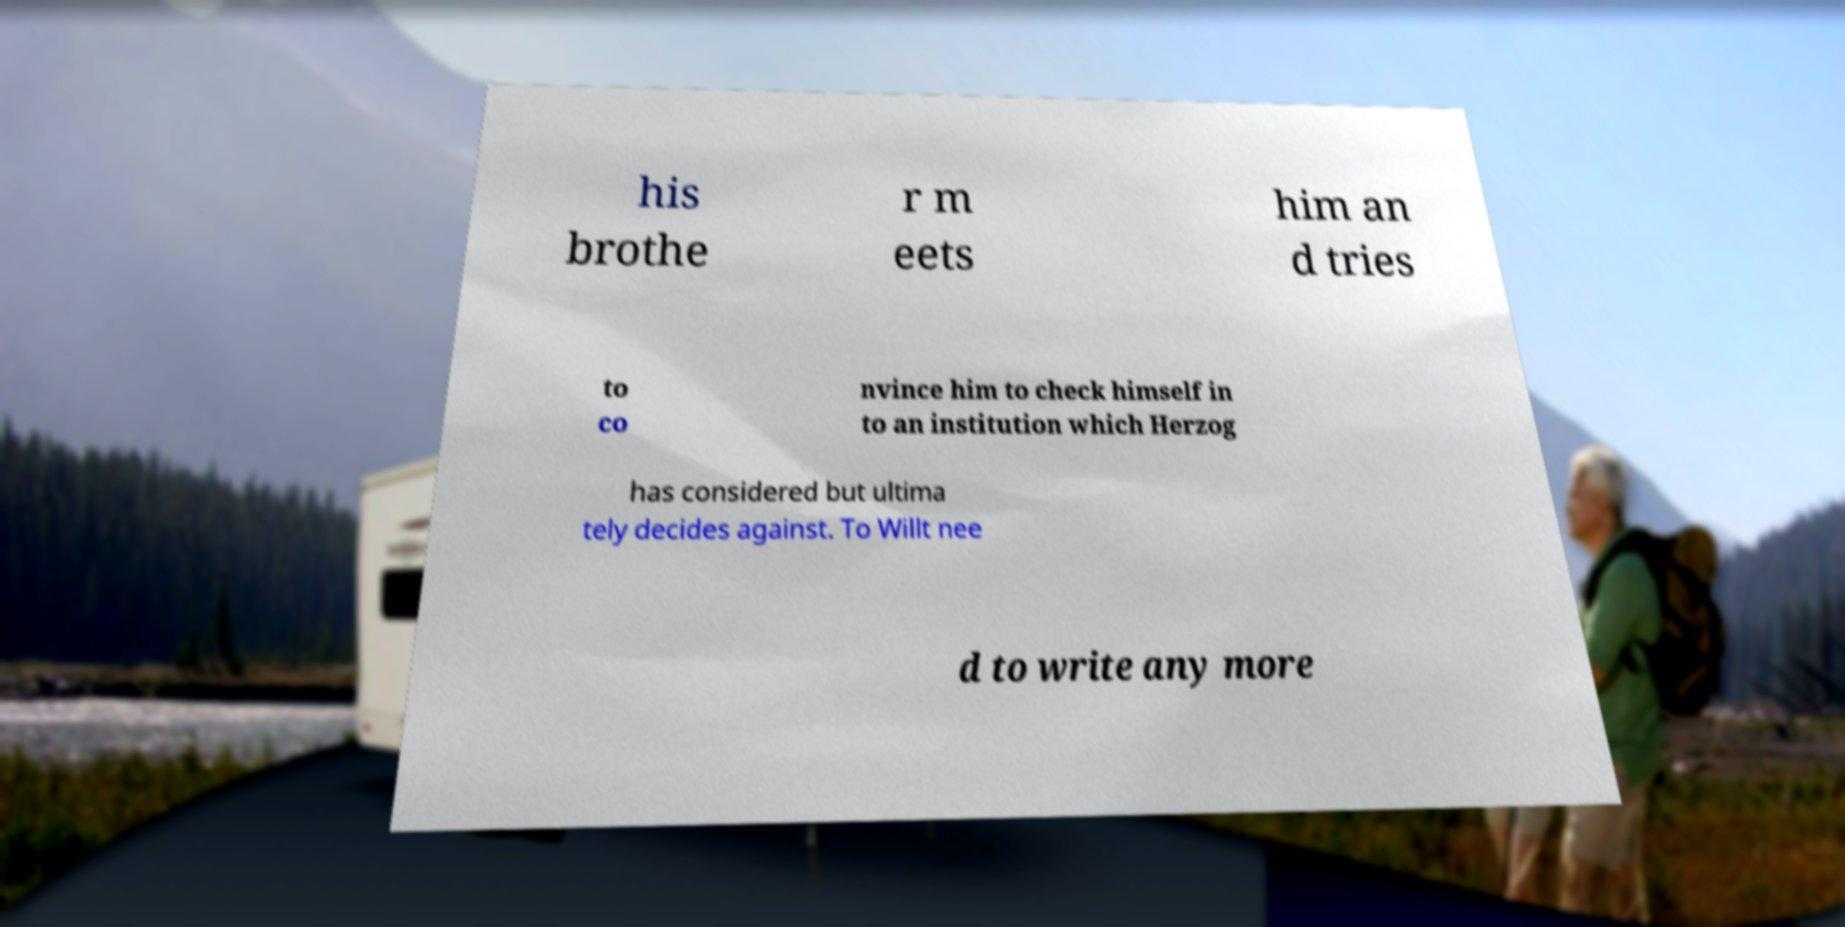There's text embedded in this image that I need extracted. Can you transcribe it verbatim? his brothe r m eets him an d tries to co nvince him to check himself in to an institution which Herzog has considered but ultima tely decides against. To Willt nee d to write any more 